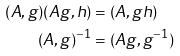Convert formula to latex. <formula><loc_0><loc_0><loc_500><loc_500>( A , g ) ( A g , h ) & = ( A , g h ) \\ ( A , g ) ^ { - 1 } & = ( A g , g ^ { - 1 } )</formula> 